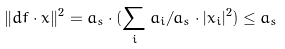<formula> <loc_0><loc_0><loc_500><loc_500>\| d f \cdot x \| ^ { 2 } = a _ { s } \cdot ( \sum _ { i } a _ { i } / a _ { s } \cdot | x _ { i } | ^ { 2 } ) \leq a _ { s }</formula> 